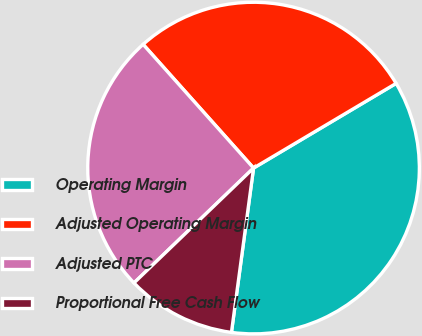<chart> <loc_0><loc_0><loc_500><loc_500><pie_chart><fcel>Operating Margin<fcel>Adjusted Operating Margin<fcel>Adjusted PTC<fcel>Proportional Free Cash Flow<nl><fcel>35.66%<fcel>28.07%<fcel>25.58%<fcel>10.69%<nl></chart> 